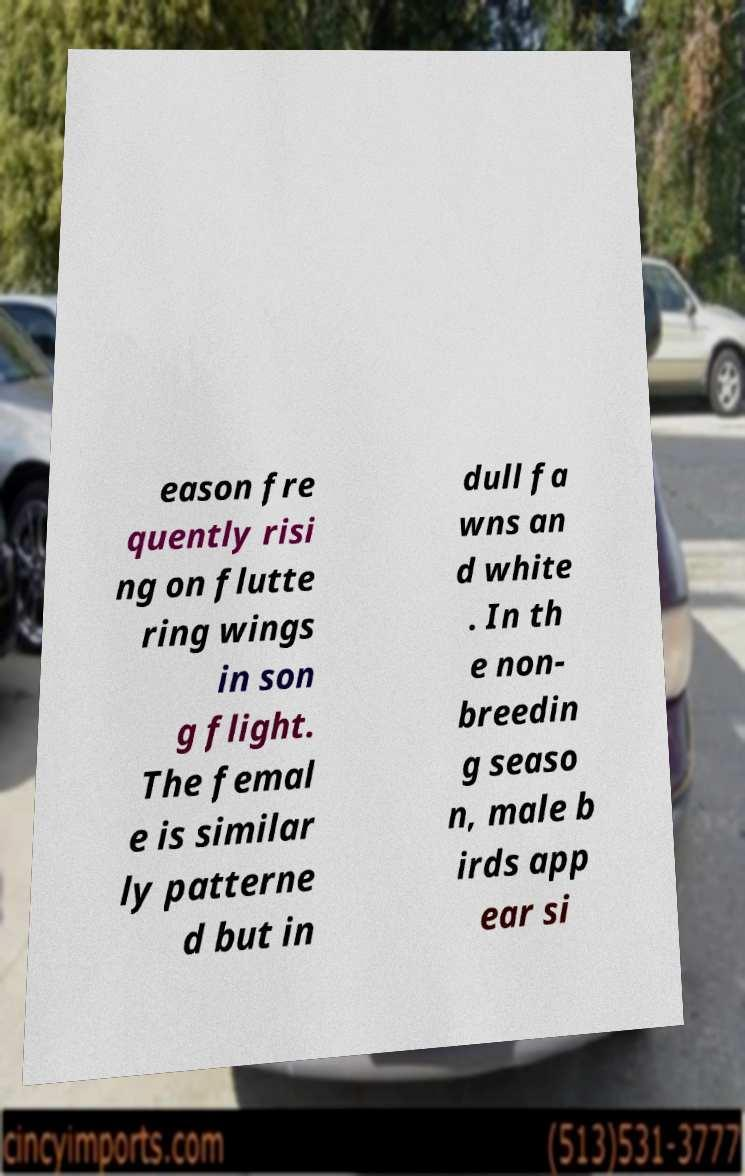For documentation purposes, I need the text within this image transcribed. Could you provide that? eason fre quently risi ng on flutte ring wings in son g flight. The femal e is similar ly patterne d but in dull fa wns an d white . In th e non- breedin g seaso n, male b irds app ear si 